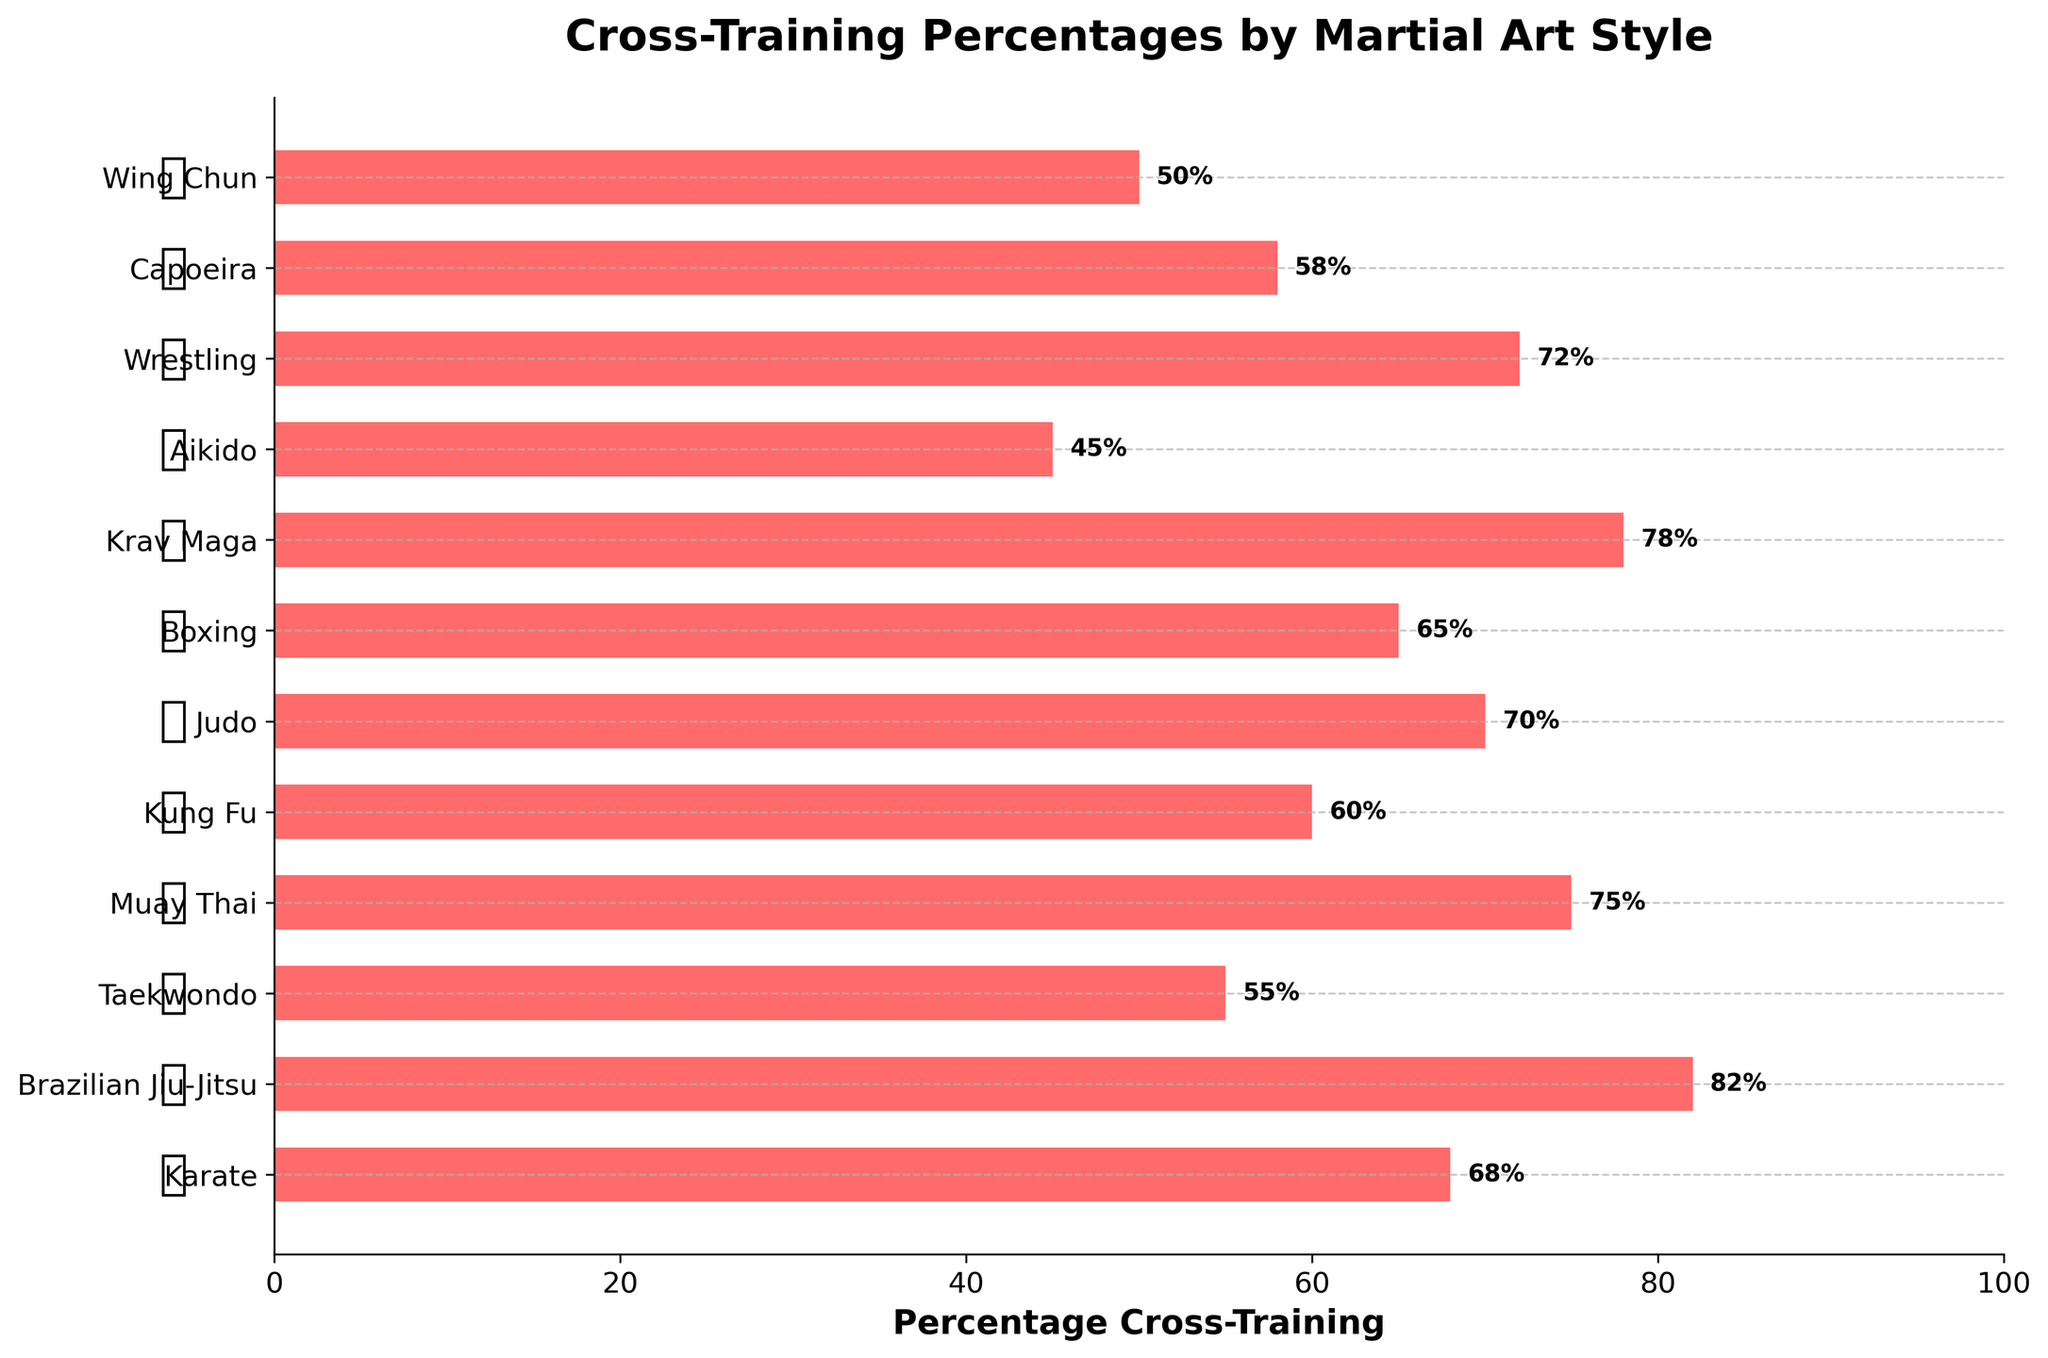Which primary style has the highest percentage of cross-training? The figure shows that Brazilian Jiu-Jitsu has the highest bar, indicating the highest percentage of cross-training.
Answer: Brazilian Jiu-Jitsu Compare the cross-training percentages of Karate and Taekwondo. Which one is higher and by how much? Karate has a cross-training percentage of 68 and Taekwondo has 55. The difference is 68 - 55 = 13. Karate's percentage is higher by 13.
Answer: Karate by 13 Which primary style has the lowest percentage of cross-training? The figure shows that Aikido has the lowest bar, indicating the lowest percentage of cross-training.
Answer: Aikido What is the average percentage of cross-training for Karate, Judo, and Boxing? Summing the percentages: Karate (68) + Judo (70) + Boxing (65) = 203. Dividing by the number of styles: 203 / 3 = 67.67.
Answer: 67.67 How many primary styles have a cross-training percentage above 70%? The figure shows Brazilian Jiu-Jitsu (82), Muay Thai (75), Krav Maga (78), and Wrestling (72). So, there are 4 styles above 70%.
Answer: 4 What is the difference in cross-training percentages between Muay Thai and Wing Chun? Muay Thai has a cross-training percentage of 75 and Wing Chun has 50. The difference is 75 - 50 = 25.
Answer: 25 Is the cross-training percentage of Capoeira greater than that of Aikido? Capoeira has a cross-training percentage of 58, while Aikido has 45. Since 58 > 45, the answer is yes.
Answer: Yes Rank the primary styles from highest to lowest based on their cross-training percentage. Based on the figure: Brazilian Jiu-Jitsu (82), Krav Maga (78), Muay Thai (75), Wrestling (72), Judo (70), Karate (68), Boxing (65), Kung Fu (60), Capoeira (58), Taekwondo (55), Wing Chun (50), Aikido (45).
Answer: BJJ, Krav Maga, Muay Thai, Wrestling, Judo, Karate, Boxing, Kung Fu, Capoeira, Taekwondo, Wing Chun, Aikido Which style has a percentage closest to the average percentage of all styles listed? The sum of all percentages is 778, and there are 12 styles, so the average is 778 / 12 = 64.83. Boxing has a percentage of 65, which is the closest.
Answer: Boxing Is there any style marked with the symbol 🥊 and how many? The figure shows 🥊 beside Muay Thai and Boxing, so there are 2 styles marked with this symbol.
Answer: 2 